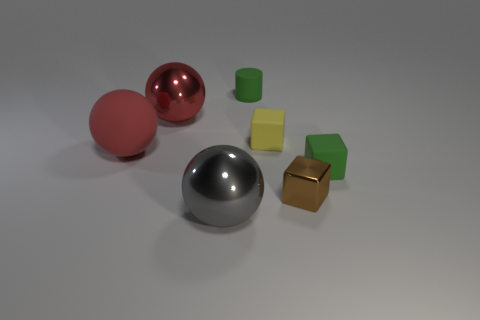Subtract all large red spheres. How many spheres are left? 1 Add 3 matte things. How many objects exist? 10 Subtract all cylinders. How many objects are left? 6 Subtract all gray balls. How many balls are left? 2 Add 3 metal objects. How many metal objects are left? 6 Add 2 green things. How many green things exist? 4 Subtract 0 blue spheres. How many objects are left? 7 Subtract 1 cylinders. How many cylinders are left? 0 Subtract all purple cylinders. Subtract all yellow blocks. How many cylinders are left? 1 Subtract all brown cubes. How many yellow spheres are left? 0 